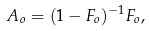<formula> <loc_0><loc_0><loc_500><loc_500>A _ { o } = ( 1 - F _ { o } ) ^ { - 1 } F _ { o } ,</formula> 